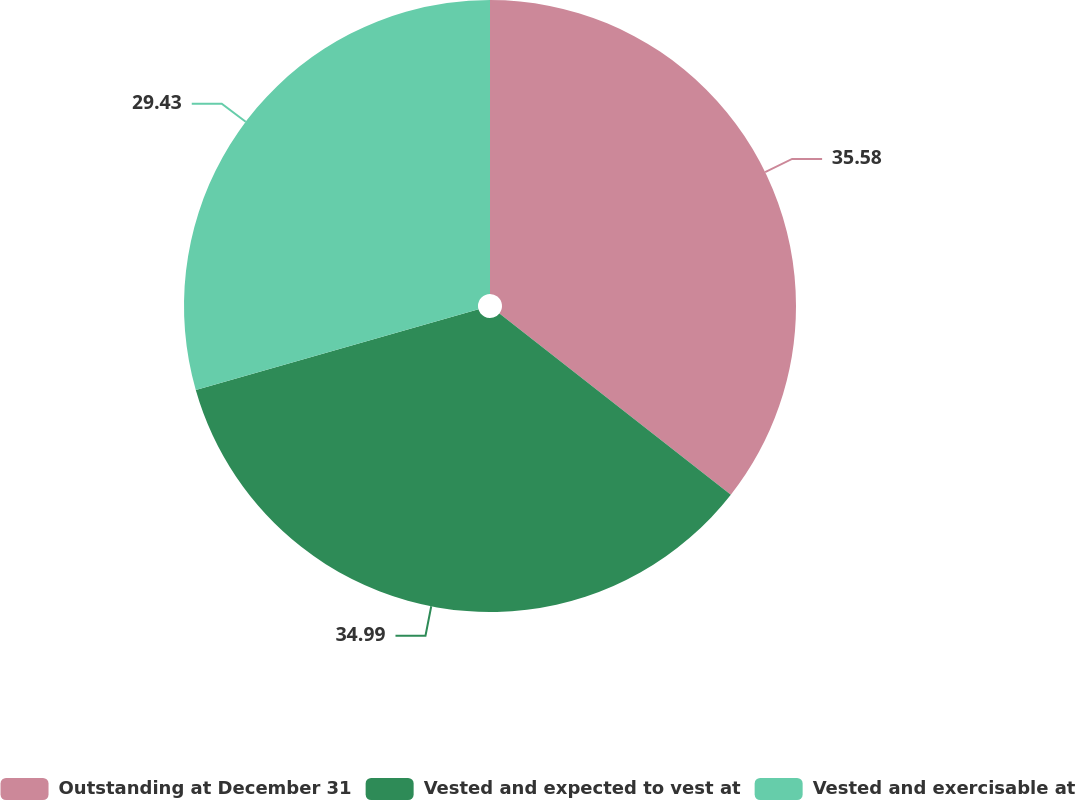Convert chart. <chart><loc_0><loc_0><loc_500><loc_500><pie_chart><fcel>Outstanding at December 31<fcel>Vested and expected to vest at<fcel>Vested and exercisable at<nl><fcel>35.58%<fcel>34.99%<fcel>29.43%<nl></chart> 